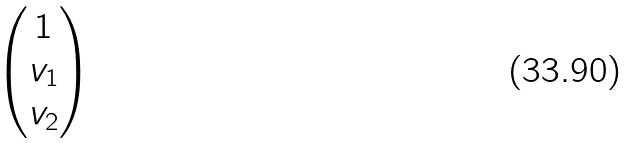<formula> <loc_0><loc_0><loc_500><loc_500>\begin{pmatrix} 1 \\ v _ { 1 } \\ v _ { 2 } \end{pmatrix}</formula> 